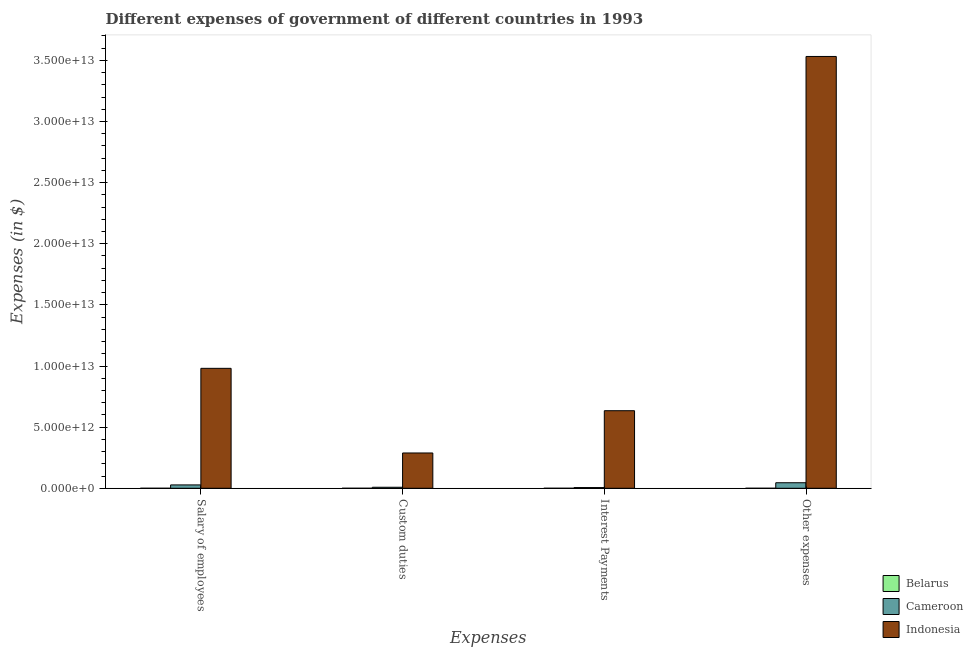How many groups of bars are there?
Make the answer very short. 4. How many bars are there on the 2nd tick from the left?
Offer a terse response. 3. How many bars are there on the 4th tick from the right?
Offer a very short reply. 3. What is the label of the 4th group of bars from the left?
Offer a terse response. Other expenses. What is the amount spent on custom duties in Belarus?
Offer a very short reply. 8.30e+06. Across all countries, what is the maximum amount spent on custom duties?
Provide a succinct answer. 2.89e+12. Across all countries, what is the minimum amount spent on interest payments?
Your response must be concise. 7.70e+06. In which country was the amount spent on interest payments minimum?
Keep it short and to the point. Belarus. What is the total amount spent on interest payments in the graph?
Provide a succinct answer. 6.40e+12. What is the difference between the amount spent on other expenses in Cameroon and that in Belarus?
Give a very brief answer. 4.53e+11. What is the difference between the amount spent on other expenses in Belarus and the amount spent on salary of employees in Indonesia?
Ensure brevity in your answer.  -9.81e+12. What is the average amount spent on interest payments per country?
Keep it short and to the point. 2.13e+12. What is the difference between the amount spent on other expenses and amount spent on interest payments in Belarus?
Keep it short and to the point. 3.50e+08. What is the ratio of the amount spent on interest payments in Indonesia to that in Cameroon?
Keep it short and to the point. 109.61. Is the difference between the amount spent on custom duties in Indonesia and Belarus greater than the difference between the amount spent on other expenses in Indonesia and Belarus?
Keep it short and to the point. No. What is the difference between the highest and the second highest amount spent on interest payments?
Your answer should be compact. 6.29e+12. What is the difference between the highest and the lowest amount spent on salary of employees?
Provide a short and direct response. 9.81e+12. In how many countries, is the amount spent on salary of employees greater than the average amount spent on salary of employees taken over all countries?
Provide a succinct answer. 1. Is it the case that in every country, the sum of the amount spent on interest payments and amount spent on custom duties is greater than the sum of amount spent on salary of employees and amount spent on other expenses?
Keep it short and to the point. No. What does the 2nd bar from the right in Interest Payments represents?
Offer a very short reply. Cameroon. Is it the case that in every country, the sum of the amount spent on salary of employees and amount spent on custom duties is greater than the amount spent on interest payments?
Keep it short and to the point. Yes. Are all the bars in the graph horizontal?
Your response must be concise. No. What is the difference between two consecutive major ticks on the Y-axis?
Give a very brief answer. 5.00e+12. Are the values on the major ticks of Y-axis written in scientific E-notation?
Ensure brevity in your answer.  Yes. Does the graph contain any zero values?
Provide a succinct answer. No. What is the title of the graph?
Make the answer very short. Different expenses of government of different countries in 1993. Does "Bolivia" appear as one of the legend labels in the graph?
Offer a terse response. No. What is the label or title of the X-axis?
Provide a succinct answer. Expenses. What is the label or title of the Y-axis?
Keep it short and to the point. Expenses (in $). What is the Expenses (in $) of Belarus in Salary of employees?
Keep it short and to the point. 1.49e+07. What is the Expenses (in $) in Cameroon in Salary of employees?
Provide a short and direct response. 2.75e+11. What is the Expenses (in $) of Indonesia in Salary of employees?
Make the answer very short. 9.81e+12. What is the Expenses (in $) of Belarus in Custom duties?
Offer a very short reply. 8.30e+06. What is the Expenses (in $) in Cameroon in Custom duties?
Provide a short and direct response. 8.33e+1. What is the Expenses (in $) of Indonesia in Custom duties?
Give a very brief answer. 2.89e+12. What is the Expenses (in $) of Belarus in Interest Payments?
Keep it short and to the point. 7.70e+06. What is the Expenses (in $) in Cameroon in Interest Payments?
Ensure brevity in your answer.  5.79e+1. What is the Expenses (in $) in Indonesia in Interest Payments?
Your response must be concise. 6.34e+12. What is the Expenses (in $) in Belarus in Other expenses?
Keep it short and to the point. 3.58e+08. What is the Expenses (in $) in Cameroon in Other expenses?
Provide a short and direct response. 4.54e+11. What is the Expenses (in $) of Indonesia in Other expenses?
Your answer should be very brief. 3.53e+13. Across all Expenses, what is the maximum Expenses (in $) in Belarus?
Provide a succinct answer. 3.58e+08. Across all Expenses, what is the maximum Expenses (in $) in Cameroon?
Keep it short and to the point. 4.54e+11. Across all Expenses, what is the maximum Expenses (in $) of Indonesia?
Provide a short and direct response. 3.53e+13. Across all Expenses, what is the minimum Expenses (in $) in Belarus?
Give a very brief answer. 7.70e+06. Across all Expenses, what is the minimum Expenses (in $) of Cameroon?
Keep it short and to the point. 5.79e+1. Across all Expenses, what is the minimum Expenses (in $) in Indonesia?
Make the answer very short. 2.89e+12. What is the total Expenses (in $) in Belarus in the graph?
Ensure brevity in your answer.  3.89e+08. What is the total Expenses (in $) of Cameroon in the graph?
Offer a terse response. 8.70e+11. What is the total Expenses (in $) in Indonesia in the graph?
Provide a succinct answer. 5.44e+13. What is the difference between the Expenses (in $) in Belarus in Salary of employees and that in Custom duties?
Make the answer very short. 6.60e+06. What is the difference between the Expenses (in $) in Cameroon in Salary of employees and that in Custom duties?
Offer a terse response. 1.92e+11. What is the difference between the Expenses (in $) in Indonesia in Salary of employees and that in Custom duties?
Your response must be concise. 6.92e+12. What is the difference between the Expenses (in $) in Belarus in Salary of employees and that in Interest Payments?
Give a very brief answer. 7.20e+06. What is the difference between the Expenses (in $) of Cameroon in Salary of employees and that in Interest Payments?
Keep it short and to the point. 2.17e+11. What is the difference between the Expenses (in $) in Indonesia in Salary of employees and that in Interest Payments?
Your response must be concise. 3.47e+12. What is the difference between the Expenses (in $) of Belarus in Salary of employees and that in Other expenses?
Give a very brief answer. -3.43e+08. What is the difference between the Expenses (in $) in Cameroon in Salary of employees and that in Other expenses?
Offer a very short reply. -1.79e+11. What is the difference between the Expenses (in $) in Indonesia in Salary of employees and that in Other expenses?
Offer a terse response. -2.55e+13. What is the difference between the Expenses (in $) in Belarus in Custom duties and that in Interest Payments?
Give a very brief answer. 6.00e+05. What is the difference between the Expenses (in $) in Cameroon in Custom duties and that in Interest Payments?
Offer a very short reply. 2.54e+1. What is the difference between the Expenses (in $) in Indonesia in Custom duties and that in Interest Payments?
Offer a terse response. -3.46e+12. What is the difference between the Expenses (in $) in Belarus in Custom duties and that in Other expenses?
Offer a terse response. -3.50e+08. What is the difference between the Expenses (in $) in Cameroon in Custom duties and that in Other expenses?
Provide a short and direct response. -3.70e+11. What is the difference between the Expenses (in $) of Indonesia in Custom duties and that in Other expenses?
Offer a very short reply. -3.24e+13. What is the difference between the Expenses (in $) of Belarus in Interest Payments and that in Other expenses?
Offer a very short reply. -3.50e+08. What is the difference between the Expenses (in $) in Cameroon in Interest Payments and that in Other expenses?
Ensure brevity in your answer.  -3.96e+11. What is the difference between the Expenses (in $) of Indonesia in Interest Payments and that in Other expenses?
Your response must be concise. -2.90e+13. What is the difference between the Expenses (in $) in Belarus in Salary of employees and the Expenses (in $) in Cameroon in Custom duties?
Your answer should be very brief. -8.33e+1. What is the difference between the Expenses (in $) in Belarus in Salary of employees and the Expenses (in $) in Indonesia in Custom duties?
Provide a succinct answer. -2.89e+12. What is the difference between the Expenses (in $) of Cameroon in Salary of employees and the Expenses (in $) of Indonesia in Custom duties?
Keep it short and to the point. -2.61e+12. What is the difference between the Expenses (in $) of Belarus in Salary of employees and the Expenses (in $) of Cameroon in Interest Payments?
Your answer should be very brief. -5.79e+1. What is the difference between the Expenses (in $) of Belarus in Salary of employees and the Expenses (in $) of Indonesia in Interest Payments?
Your response must be concise. -6.34e+12. What is the difference between the Expenses (in $) in Cameroon in Salary of employees and the Expenses (in $) in Indonesia in Interest Payments?
Offer a very short reply. -6.07e+12. What is the difference between the Expenses (in $) in Belarus in Salary of employees and the Expenses (in $) in Cameroon in Other expenses?
Your answer should be very brief. -4.54e+11. What is the difference between the Expenses (in $) of Belarus in Salary of employees and the Expenses (in $) of Indonesia in Other expenses?
Provide a succinct answer. -3.53e+13. What is the difference between the Expenses (in $) of Cameroon in Salary of employees and the Expenses (in $) of Indonesia in Other expenses?
Give a very brief answer. -3.50e+13. What is the difference between the Expenses (in $) of Belarus in Custom duties and the Expenses (in $) of Cameroon in Interest Payments?
Offer a terse response. -5.79e+1. What is the difference between the Expenses (in $) of Belarus in Custom duties and the Expenses (in $) of Indonesia in Interest Payments?
Keep it short and to the point. -6.34e+12. What is the difference between the Expenses (in $) in Cameroon in Custom duties and the Expenses (in $) in Indonesia in Interest Payments?
Your response must be concise. -6.26e+12. What is the difference between the Expenses (in $) of Belarus in Custom duties and the Expenses (in $) of Cameroon in Other expenses?
Provide a short and direct response. -4.54e+11. What is the difference between the Expenses (in $) of Belarus in Custom duties and the Expenses (in $) of Indonesia in Other expenses?
Keep it short and to the point. -3.53e+13. What is the difference between the Expenses (in $) of Cameroon in Custom duties and the Expenses (in $) of Indonesia in Other expenses?
Make the answer very short. -3.52e+13. What is the difference between the Expenses (in $) in Belarus in Interest Payments and the Expenses (in $) in Cameroon in Other expenses?
Offer a very short reply. -4.54e+11. What is the difference between the Expenses (in $) of Belarus in Interest Payments and the Expenses (in $) of Indonesia in Other expenses?
Keep it short and to the point. -3.53e+13. What is the difference between the Expenses (in $) in Cameroon in Interest Payments and the Expenses (in $) in Indonesia in Other expenses?
Provide a short and direct response. -3.53e+13. What is the average Expenses (in $) in Belarus per Expenses?
Offer a terse response. 9.73e+07. What is the average Expenses (in $) of Cameroon per Expenses?
Ensure brevity in your answer.  2.17e+11. What is the average Expenses (in $) in Indonesia per Expenses?
Give a very brief answer. 1.36e+13. What is the difference between the Expenses (in $) in Belarus and Expenses (in $) in Cameroon in Salary of employees?
Your response must be concise. -2.75e+11. What is the difference between the Expenses (in $) of Belarus and Expenses (in $) of Indonesia in Salary of employees?
Keep it short and to the point. -9.81e+12. What is the difference between the Expenses (in $) in Cameroon and Expenses (in $) in Indonesia in Salary of employees?
Provide a short and direct response. -9.54e+12. What is the difference between the Expenses (in $) of Belarus and Expenses (in $) of Cameroon in Custom duties?
Provide a short and direct response. -8.33e+1. What is the difference between the Expenses (in $) of Belarus and Expenses (in $) of Indonesia in Custom duties?
Keep it short and to the point. -2.89e+12. What is the difference between the Expenses (in $) of Cameroon and Expenses (in $) of Indonesia in Custom duties?
Offer a very short reply. -2.80e+12. What is the difference between the Expenses (in $) of Belarus and Expenses (in $) of Cameroon in Interest Payments?
Make the answer very short. -5.79e+1. What is the difference between the Expenses (in $) in Belarus and Expenses (in $) in Indonesia in Interest Payments?
Keep it short and to the point. -6.34e+12. What is the difference between the Expenses (in $) in Cameroon and Expenses (in $) in Indonesia in Interest Payments?
Make the answer very short. -6.29e+12. What is the difference between the Expenses (in $) of Belarus and Expenses (in $) of Cameroon in Other expenses?
Provide a short and direct response. -4.53e+11. What is the difference between the Expenses (in $) in Belarus and Expenses (in $) in Indonesia in Other expenses?
Offer a very short reply. -3.53e+13. What is the difference between the Expenses (in $) of Cameroon and Expenses (in $) of Indonesia in Other expenses?
Keep it short and to the point. -3.49e+13. What is the ratio of the Expenses (in $) of Belarus in Salary of employees to that in Custom duties?
Make the answer very short. 1.8. What is the ratio of the Expenses (in $) of Cameroon in Salary of employees to that in Custom duties?
Make the answer very short. 3.3. What is the ratio of the Expenses (in $) of Indonesia in Salary of employees to that in Custom duties?
Your answer should be compact. 3.4. What is the ratio of the Expenses (in $) in Belarus in Salary of employees to that in Interest Payments?
Your answer should be very brief. 1.94. What is the ratio of the Expenses (in $) in Cameroon in Salary of employees to that in Interest Payments?
Your answer should be compact. 4.75. What is the ratio of the Expenses (in $) of Indonesia in Salary of employees to that in Interest Payments?
Offer a very short reply. 1.55. What is the ratio of the Expenses (in $) in Belarus in Salary of employees to that in Other expenses?
Offer a very short reply. 0.04. What is the ratio of the Expenses (in $) of Cameroon in Salary of employees to that in Other expenses?
Keep it short and to the point. 0.61. What is the ratio of the Expenses (in $) of Indonesia in Salary of employees to that in Other expenses?
Your response must be concise. 0.28. What is the ratio of the Expenses (in $) of Belarus in Custom duties to that in Interest Payments?
Your answer should be very brief. 1.08. What is the ratio of the Expenses (in $) in Cameroon in Custom duties to that in Interest Payments?
Offer a terse response. 1.44. What is the ratio of the Expenses (in $) of Indonesia in Custom duties to that in Interest Payments?
Provide a succinct answer. 0.46. What is the ratio of the Expenses (in $) of Belarus in Custom duties to that in Other expenses?
Your answer should be very brief. 0.02. What is the ratio of the Expenses (in $) of Cameroon in Custom duties to that in Other expenses?
Your answer should be very brief. 0.18. What is the ratio of the Expenses (in $) in Indonesia in Custom duties to that in Other expenses?
Your answer should be compact. 0.08. What is the ratio of the Expenses (in $) in Belarus in Interest Payments to that in Other expenses?
Ensure brevity in your answer.  0.02. What is the ratio of the Expenses (in $) of Cameroon in Interest Payments to that in Other expenses?
Give a very brief answer. 0.13. What is the ratio of the Expenses (in $) of Indonesia in Interest Payments to that in Other expenses?
Offer a very short reply. 0.18. What is the difference between the highest and the second highest Expenses (in $) of Belarus?
Your response must be concise. 3.43e+08. What is the difference between the highest and the second highest Expenses (in $) of Cameroon?
Ensure brevity in your answer.  1.79e+11. What is the difference between the highest and the second highest Expenses (in $) of Indonesia?
Ensure brevity in your answer.  2.55e+13. What is the difference between the highest and the lowest Expenses (in $) in Belarus?
Make the answer very short. 3.50e+08. What is the difference between the highest and the lowest Expenses (in $) in Cameroon?
Your answer should be very brief. 3.96e+11. What is the difference between the highest and the lowest Expenses (in $) of Indonesia?
Offer a very short reply. 3.24e+13. 